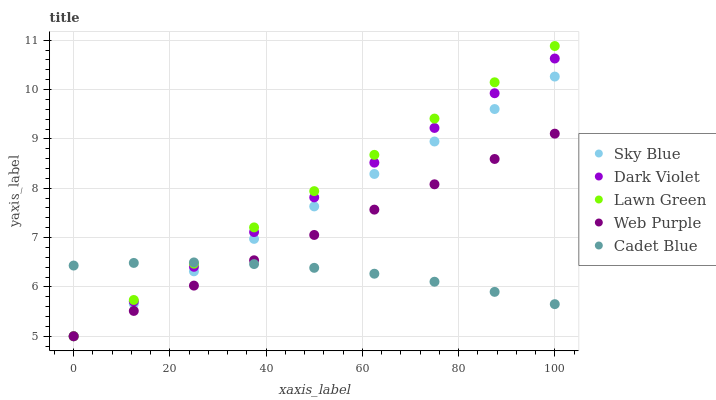Does Cadet Blue have the minimum area under the curve?
Answer yes or no. Yes. Does Lawn Green have the maximum area under the curve?
Answer yes or no. Yes. Does Web Purple have the minimum area under the curve?
Answer yes or no. No. Does Web Purple have the maximum area under the curve?
Answer yes or no. No. Is Sky Blue the smoothest?
Answer yes or no. Yes. Is Cadet Blue the roughest?
Answer yes or no. Yes. Is Web Purple the smoothest?
Answer yes or no. No. Is Web Purple the roughest?
Answer yes or no. No. Does Sky Blue have the lowest value?
Answer yes or no. Yes. Does Cadet Blue have the lowest value?
Answer yes or no. No. Does Lawn Green have the highest value?
Answer yes or no. Yes. Does Web Purple have the highest value?
Answer yes or no. No. Does Dark Violet intersect Sky Blue?
Answer yes or no. Yes. Is Dark Violet less than Sky Blue?
Answer yes or no. No. Is Dark Violet greater than Sky Blue?
Answer yes or no. No. 